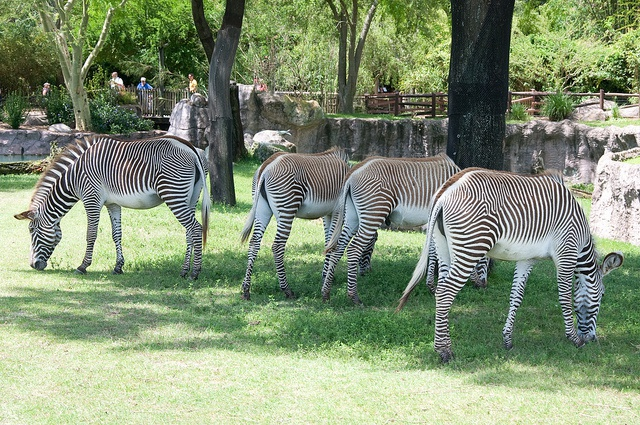Describe the objects in this image and their specific colors. I can see zebra in olive, lightgray, gray, darkgray, and black tones, zebra in olive, black, gray, darkgray, and lightgray tones, zebra in olive, darkgray, gray, black, and lightgray tones, zebra in olive, gray, darkgray, black, and lightgray tones, and people in olive, white, darkgray, and gray tones in this image. 